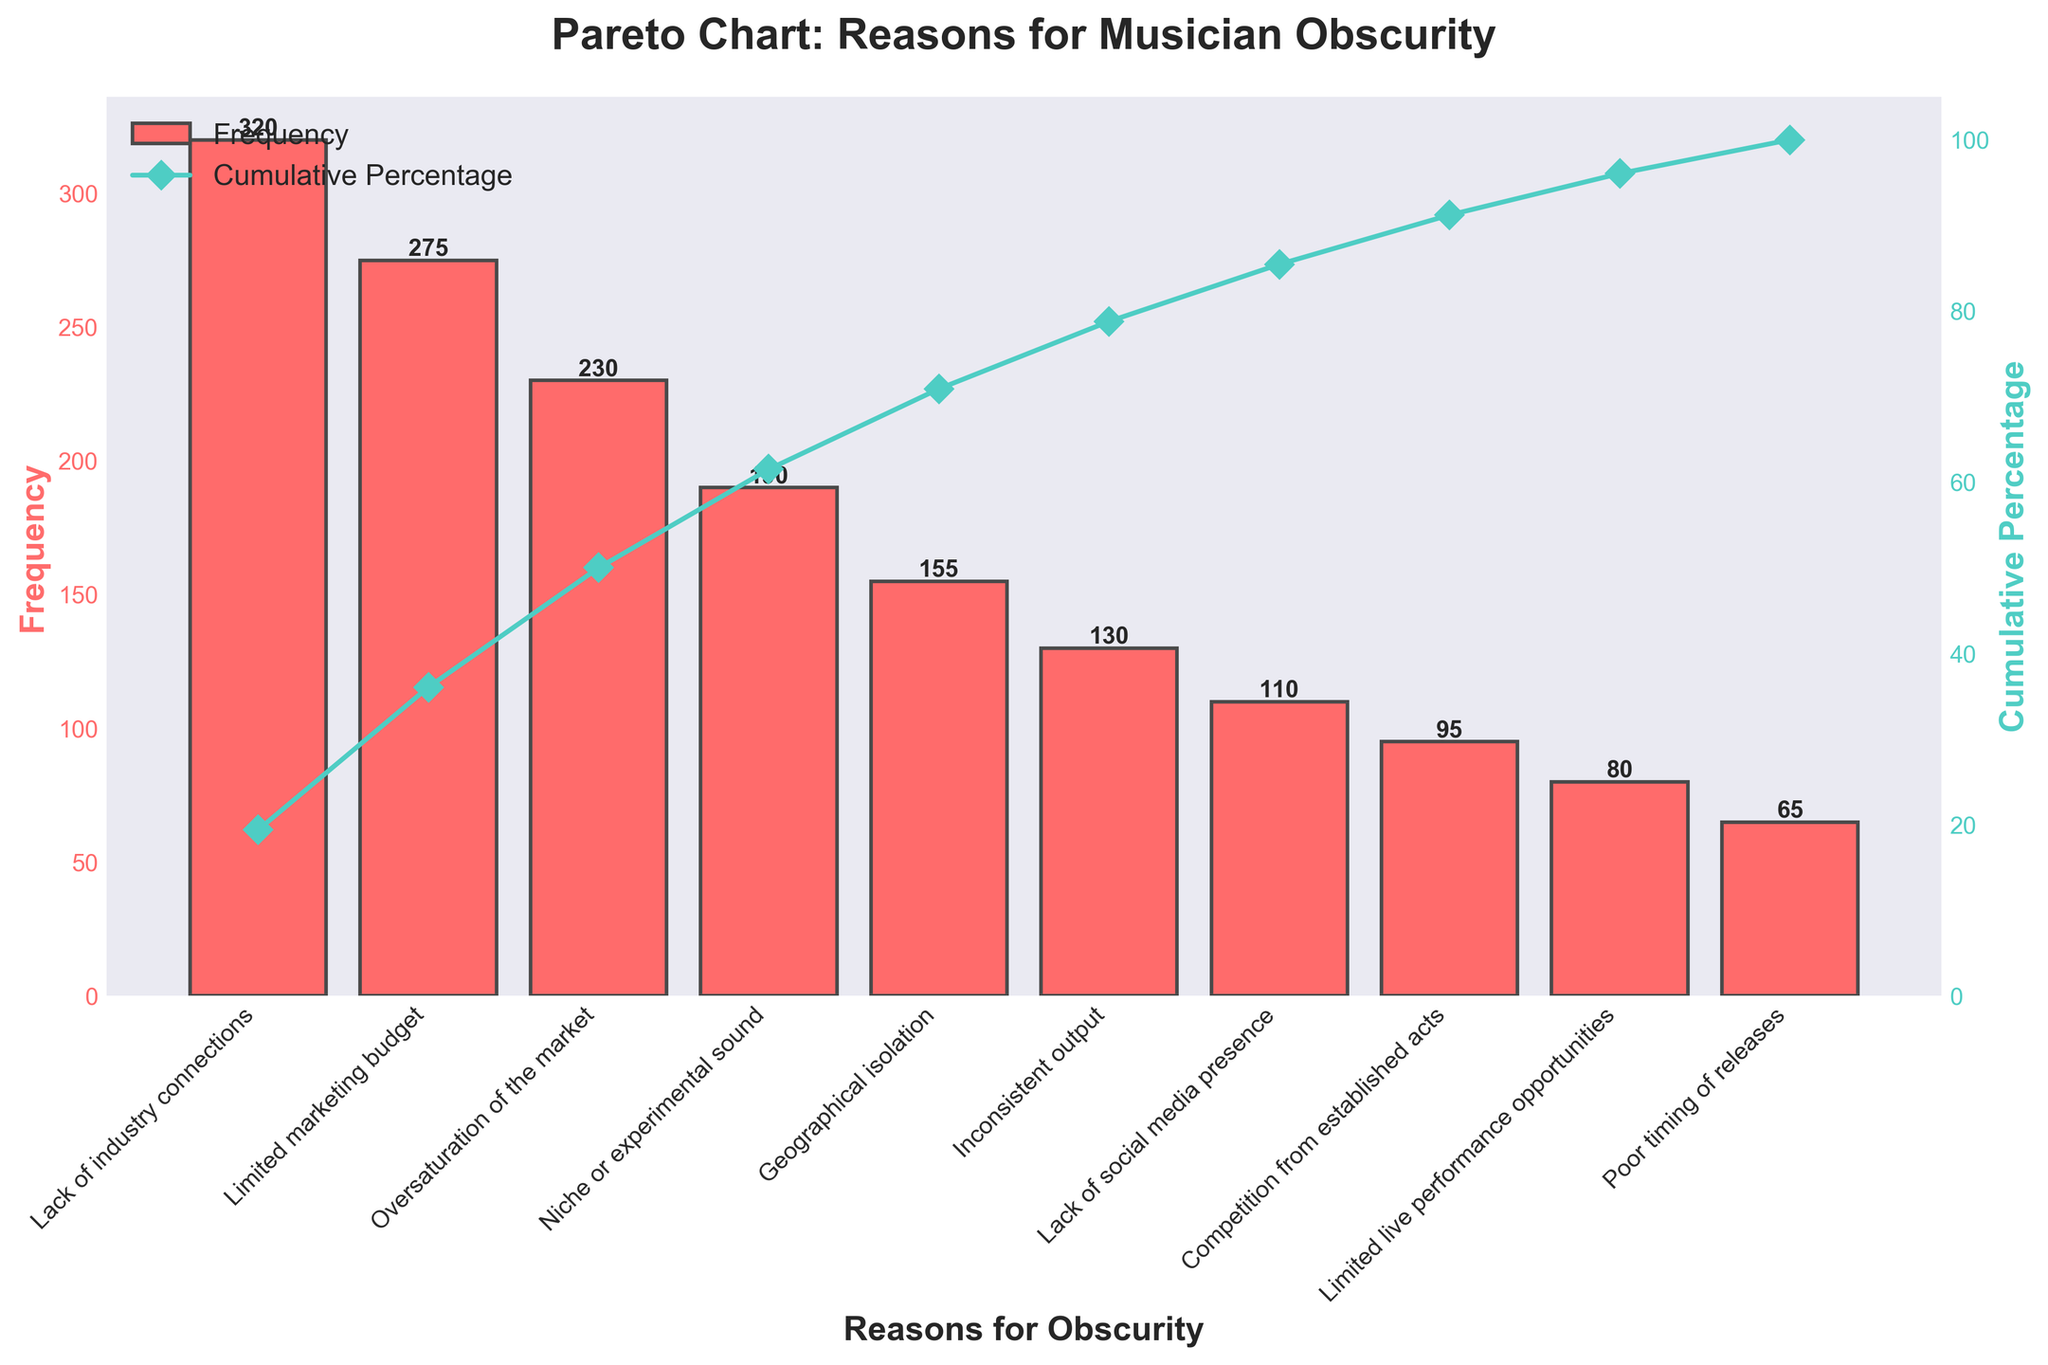What is the title of the figure? The title is prominently displayed at the top of the figure and is written as "Pareto Chart: Reasons for Musician Obscurity".
Answer: Pareto Chart: Reasons for Musician Obscurity How many reasons for musician obscurity are listed in the figure? The x-axis lists the different reasons, which can be counted directly from the figure. There are 10 bars along the x-axis, each representing a different reason.
Answer: 10 Which reason is the most common for musician obscurity? By looking at the bars, the reason with the highest bar indicates the most common reason. The highest bar corresponds to "Lack of industry connections".
Answer: Lack of industry connections What is the cumulative percentage at "Limited marketing budget"? The cumulative percentage line intersects with the "Limited marketing budget" bar, and by following it to the right y-axis, the exact value is read.
Answer: 33.57% How many reasons contribute to at least 75% of the total frequency? Identify the bars until the cumulative percentage line reaches 75%, then count these bars. The cumulative percentage reaches 75% before the sixth reason.
Answer: 5 Which reason has a frequency closest to half of "Lack of industry connections"? "Lack of industry connections" has a frequency of 320, so half of that is 160. "Geographical isolation" has a frequency of 155, which is closest.
Answer: Geographical isolation What is the difference in frequency between "Oversaturation of the market" and "Inconsistent output"? The difference can be calculated by subtracting the frequency of "Inconsistent output" (130) from the frequency of "Oversaturation of the market" (230).
Answer: 100 Does the frequency for "Niche or experimental sound" fall above or below the average frequency? Calculate the average frequency by summing all frequencies and dividing by the number of reasons. Compare the frequency of "Niche or experimental sound" (190) to this average (215).
Answer: Below Which reason has the smallest impact on musician obscurity? The smallest impact is indicated by the shortest bar in the chart, corresponding to "Poor timing of releases".
Answer: Poor timing of releases By how much does the frequency of "Lack of social media presence" exceed that of "Limited live performance opportunities"? The frequencies for "Lack of social media presence" (110) and "Limited live performance opportunities" (80) can be subtracted to find the difference.
Answer: 30 